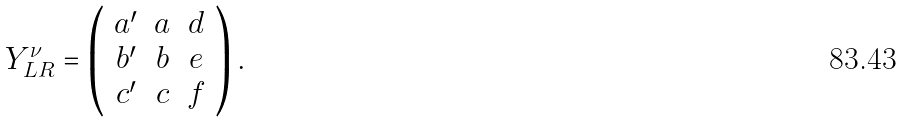<formula> <loc_0><loc_0><loc_500><loc_500>Y ^ { \nu } _ { L R } = \left ( \begin{array} { c c c } a ^ { \prime } & a & d \\ b ^ { \prime } & b & e \\ c ^ { \prime } & c & f \end{array} \right ) .</formula> 